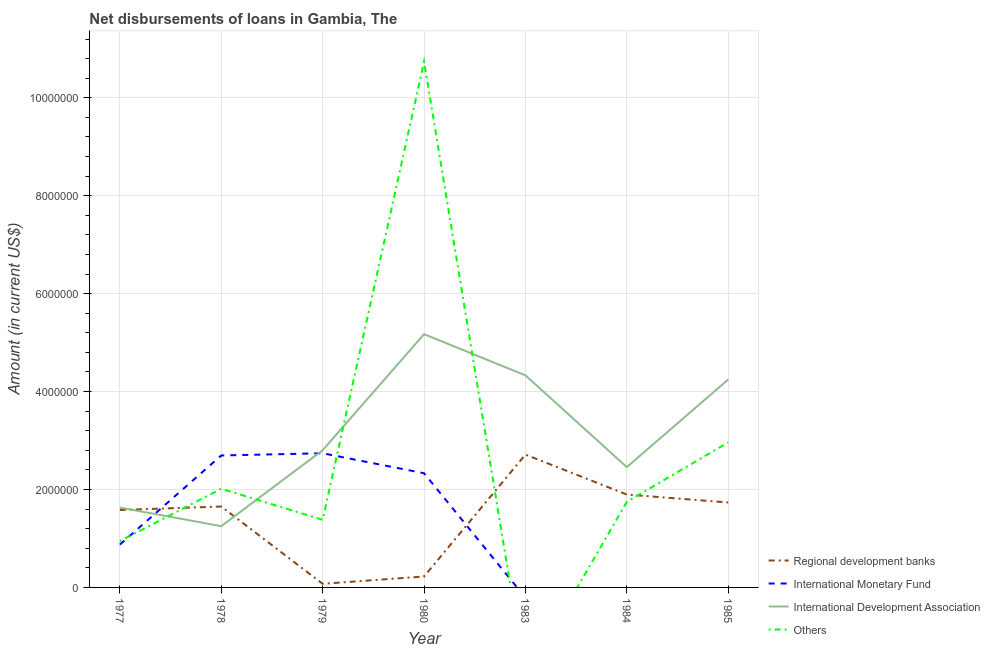How many different coloured lines are there?
Make the answer very short. 4. Is the number of lines equal to the number of legend labels?
Your answer should be compact. No. What is the amount of loan disimbursed by other organisations in 1978?
Your answer should be very brief. 2.02e+06. Across all years, what is the maximum amount of loan disimbursed by regional development banks?
Ensure brevity in your answer.  2.71e+06. In which year was the amount of loan disimbursed by international development association maximum?
Offer a very short reply. 1980. What is the total amount of loan disimbursed by other organisations in the graph?
Keep it short and to the point. 1.98e+07. What is the difference between the amount of loan disimbursed by international development association in 1978 and that in 1985?
Provide a succinct answer. -3.00e+06. What is the difference between the amount of loan disimbursed by other organisations in 1984 and the amount of loan disimbursed by regional development banks in 1983?
Provide a short and direct response. -9.65e+05. What is the average amount of loan disimbursed by international monetary fund per year?
Your answer should be compact. 1.23e+06. In the year 1979, what is the difference between the amount of loan disimbursed by other organisations and amount of loan disimbursed by international monetary fund?
Keep it short and to the point. -1.36e+06. What is the ratio of the amount of loan disimbursed by regional development banks in 1979 to that in 1984?
Give a very brief answer. 0.04. Is the amount of loan disimbursed by international development association in 1977 less than that in 1983?
Ensure brevity in your answer.  Yes. What is the difference between the highest and the second highest amount of loan disimbursed by other organisations?
Ensure brevity in your answer.  7.78e+06. What is the difference between the highest and the lowest amount of loan disimbursed by international monetary fund?
Keep it short and to the point. 2.74e+06. Does the amount of loan disimbursed by international development association monotonically increase over the years?
Keep it short and to the point. No. Is the amount of loan disimbursed by international monetary fund strictly greater than the amount of loan disimbursed by regional development banks over the years?
Provide a short and direct response. No. How many lines are there?
Offer a very short reply. 4. Are the values on the major ticks of Y-axis written in scientific E-notation?
Offer a terse response. No. Where does the legend appear in the graph?
Provide a short and direct response. Bottom right. How are the legend labels stacked?
Keep it short and to the point. Vertical. What is the title of the graph?
Ensure brevity in your answer.  Net disbursements of loans in Gambia, The. What is the label or title of the X-axis?
Your answer should be very brief. Year. What is the Amount (in current US$) in Regional development banks in 1977?
Keep it short and to the point. 1.58e+06. What is the Amount (in current US$) of International Monetary Fund in 1977?
Your answer should be compact. 8.75e+05. What is the Amount (in current US$) of International Development Association in 1977?
Provide a short and direct response. 1.63e+06. What is the Amount (in current US$) in Others in 1977?
Provide a short and direct response. 9.45e+05. What is the Amount (in current US$) in Regional development banks in 1978?
Provide a succinct answer. 1.65e+06. What is the Amount (in current US$) of International Monetary Fund in 1978?
Your response must be concise. 2.70e+06. What is the Amount (in current US$) in International Development Association in 1978?
Offer a very short reply. 1.25e+06. What is the Amount (in current US$) of Others in 1978?
Ensure brevity in your answer.  2.02e+06. What is the Amount (in current US$) in Regional development banks in 1979?
Offer a terse response. 7.40e+04. What is the Amount (in current US$) in International Monetary Fund in 1979?
Keep it short and to the point. 2.74e+06. What is the Amount (in current US$) in International Development Association in 1979?
Your answer should be compact. 2.80e+06. What is the Amount (in current US$) of Others in 1979?
Offer a very short reply. 1.38e+06. What is the Amount (in current US$) in Regional development banks in 1980?
Offer a very short reply. 2.23e+05. What is the Amount (in current US$) of International Monetary Fund in 1980?
Your response must be concise. 2.33e+06. What is the Amount (in current US$) of International Development Association in 1980?
Give a very brief answer. 5.17e+06. What is the Amount (in current US$) of Others in 1980?
Offer a very short reply. 1.07e+07. What is the Amount (in current US$) in Regional development banks in 1983?
Offer a very short reply. 2.71e+06. What is the Amount (in current US$) of International Monetary Fund in 1983?
Ensure brevity in your answer.  0. What is the Amount (in current US$) in International Development Association in 1983?
Provide a succinct answer. 4.33e+06. What is the Amount (in current US$) of Others in 1983?
Make the answer very short. 0. What is the Amount (in current US$) in Regional development banks in 1984?
Provide a succinct answer. 1.90e+06. What is the Amount (in current US$) of International Development Association in 1984?
Offer a terse response. 2.46e+06. What is the Amount (in current US$) in Others in 1984?
Offer a very short reply. 1.75e+06. What is the Amount (in current US$) of Regional development banks in 1985?
Provide a short and direct response. 1.74e+06. What is the Amount (in current US$) of International Monetary Fund in 1985?
Make the answer very short. 0. What is the Amount (in current US$) of International Development Association in 1985?
Make the answer very short. 4.25e+06. What is the Amount (in current US$) of Others in 1985?
Give a very brief answer. 2.96e+06. Across all years, what is the maximum Amount (in current US$) of Regional development banks?
Offer a terse response. 2.71e+06. Across all years, what is the maximum Amount (in current US$) in International Monetary Fund?
Offer a very short reply. 2.74e+06. Across all years, what is the maximum Amount (in current US$) in International Development Association?
Your response must be concise. 5.17e+06. Across all years, what is the maximum Amount (in current US$) of Others?
Your response must be concise. 1.07e+07. Across all years, what is the minimum Amount (in current US$) of Regional development banks?
Provide a succinct answer. 7.40e+04. Across all years, what is the minimum Amount (in current US$) of International Development Association?
Keep it short and to the point. 1.25e+06. Across all years, what is the minimum Amount (in current US$) of Others?
Your answer should be compact. 0. What is the total Amount (in current US$) in Regional development banks in the graph?
Ensure brevity in your answer.  9.88e+06. What is the total Amount (in current US$) in International Monetary Fund in the graph?
Ensure brevity in your answer.  8.64e+06. What is the total Amount (in current US$) of International Development Association in the graph?
Your answer should be compact. 2.19e+07. What is the total Amount (in current US$) of Others in the graph?
Provide a short and direct response. 1.98e+07. What is the difference between the Amount (in current US$) of International Monetary Fund in 1977 and that in 1978?
Make the answer very short. -1.82e+06. What is the difference between the Amount (in current US$) of International Development Association in 1977 and that in 1978?
Offer a terse response. 3.80e+05. What is the difference between the Amount (in current US$) in Others in 1977 and that in 1978?
Your answer should be compact. -1.07e+06. What is the difference between the Amount (in current US$) of Regional development banks in 1977 and that in 1979?
Your answer should be compact. 1.51e+06. What is the difference between the Amount (in current US$) of International Monetary Fund in 1977 and that in 1979?
Make the answer very short. -1.86e+06. What is the difference between the Amount (in current US$) in International Development Association in 1977 and that in 1979?
Make the answer very short. -1.17e+06. What is the difference between the Amount (in current US$) in Others in 1977 and that in 1979?
Give a very brief answer. -4.36e+05. What is the difference between the Amount (in current US$) of Regional development banks in 1977 and that in 1980?
Give a very brief answer. 1.36e+06. What is the difference between the Amount (in current US$) of International Monetary Fund in 1977 and that in 1980?
Offer a terse response. -1.46e+06. What is the difference between the Amount (in current US$) of International Development Association in 1977 and that in 1980?
Provide a succinct answer. -3.54e+06. What is the difference between the Amount (in current US$) in Others in 1977 and that in 1980?
Offer a terse response. -9.79e+06. What is the difference between the Amount (in current US$) of Regional development banks in 1977 and that in 1983?
Keep it short and to the point. -1.13e+06. What is the difference between the Amount (in current US$) of International Development Association in 1977 and that in 1983?
Provide a short and direct response. -2.70e+06. What is the difference between the Amount (in current US$) in Regional development banks in 1977 and that in 1984?
Keep it short and to the point. -3.15e+05. What is the difference between the Amount (in current US$) of International Development Association in 1977 and that in 1984?
Ensure brevity in your answer.  -8.26e+05. What is the difference between the Amount (in current US$) of Others in 1977 and that in 1984?
Ensure brevity in your answer.  -8.03e+05. What is the difference between the Amount (in current US$) in Regional development banks in 1977 and that in 1985?
Offer a terse response. -1.53e+05. What is the difference between the Amount (in current US$) of International Development Association in 1977 and that in 1985?
Keep it short and to the point. -2.62e+06. What is the difference between the Amount (in current US$) in Others in 1977 and that in 1985?
Your answer should be compact. -2.02e+06. What is the difference between the Amount (in current US$) of Regional development banks in 1978 and that in 1979?
Offer a very short reply. 1.58e+06. What is the difference between the Amount (in current US$) in International Monetary Fund in 1978 and that in 1979?
Provide a short and direct response. -4.50e+04. What is the difference between the Amount (in current US$) in International Development Association in 1978 and that in 1979?
Provide a succinct answer. -1.55e+06. What is the difference between the Amount (in current US$) in Others in 1978 and that in 1979?
Offer a very short reply. 6.34e+05. What is the difference between the Amount (in current US$) in Regional development banks in 1978 and that in 1980?
Your answer should be compact. 1.43e+06. What is the difference between the Amount (in current US$) in International Monetary Fund in 1978 and that in 1980?
Offer a terse response. 3.63e+05. What is the difference between the Amount (in current US$) of International Development Association in 1978 and that in 1980?
Give a very brief answer. -3.92e+06. What is the difference between the Amount (in current US$) in Others in 1978 and that in 1980?
Your response must be concise. -8.72e+06. What is the difference between the Amount (in current US$) of Regional development banks in 1978 and that in 1983?
Offer a very short reply. -1.06e+06. What is the difference between the Amount (in current US$) in International Development Association in 1978 and that in 1983?
Offer a very short reply. -3.08e+06. What is the difference between the Amount (in current US$) of Regional development banks in 1978 and that in 1984?
Provide a succinct answer. -2.45e+05. What is the difference between the Amount (in current US$) in International Development Association in 1978 and that in 1984?
Keep it short and to the point. -1.21e+06. What is the difference between the Amount (in current US$) in Others in 1978 and that in 1984?
Your answer should be compact. 2.67e+05. What is the difference between the Amount (in current US$) of Regional development banks in 1978 and that in 1985?
Your answer should be compact. -8.30e+04. What is the difference between the Amount (in current US$) in International Development Association in 1978 and that in 1985?
Provide a succinct answer. -3.00e+06. What is the difference between the Amount (in current US$) in Others in 1978 and that in 1985?
Provide a succinct answer. -9.48e+05. What is the difference between the Amount (in current US$) in Regional development banks in 1979 and that in 1980?
Make the answer very short. -1.49e+05. What is the difference between the Amount (in current US$) of International Monetary Fund in 1979 and that in 1980?
Your answer should be very brief. 4.08e+05. What is the difference between the Amount (in current US$) of International Development Association in 1979 and that in 1980?
Give a very brief answer. -2.37e+06. What is the difference between the Amount (in current US$) in Others in 1979 and that in 1980?
Keep it short and to the point. -9.36e+06. What is the difference between the Amount (in current US$) in Regional development banks in 1979 and that in 1983?
Keep it short and to the point. -2.64e+06. What is the difference between the Amount (in current US$) in International Development Association in 1979 and that in 1983?
Keep it short and to the point. -1.53e+06. What is the difference between the Amount (in current US$) in Regional development banks in 1979 and that in 1984?
Keep it short and to the point. -1.82e+06. What is the difference between the Amount (in current US$) of International Development Association in 1979 and that in 1984?
Provide a succinct answer. 3.46e+05. What is the difference between the Amount (in current US$) in Others in 1979 and that in 1984?
Keep it short and to the point. -3.67e+05. What is the difference between the Amount (in current US$) of Regional development banks in 1979 and that in 1985?
Your answer should be very brief. -1.66e+06. What is the difference between the Amount (in current US$) in International Development Association in 1979 and that in 1985?
Ensure brevity in your answer.  -1.44e+06. What is the difference between the Amount (in current US$) in Others in 1979 and that in 1985?
Your response must be concise. -1.58e+06. What is the difference between the Amount (in current US$) of Regional development banks in 1980 and that in 1983?
Make the answer very short. -2.49e+06. What is the difference between the Amount (in current US$) in International Development Association in 1980 and that in 1983?
Offer a terse response. 8.41e+05. What is the difference between the Amount (in current US$) of Regional development banks in 1980 and that in 1984?
Make the answer very short. -1.67e+06. What is the difference between the Amount (in current US$) of International Development Association in 1980 and that in 1984?
Make the answer very short. 2.72e+06. What is the difference between the Amount (in current US$) in Others in 1980 and that in 1984?
Provide a succinct answer. 8.99e+06. What is the difference between the Amount (in current US$) in Regional development banks in 1980 and that in 1985?
Offer a very short reply. -1.51e+06. What is the difference between the Amount (in current US$) in International Development Association in 1980 and that in 1985?
Your response must be concise. 9.25e+05. What is the difference between the Amount (in current US$) of Others in 1980 and that in 1985?
Offer a very short reply. 7.78e+06. What is the difference between the Amount (in current US$) in Regional development banks in 1983 and that in 1984?
Make the answer very short. 8.16e+05. What is the difference between the Amount (in current US$) in International Development Association in 1983 and that in 1984?
Make the answer very short. 1.87e+06. What is the difference between the Amount (in current US$) in Regional development banks in 1983 and that in 1985?
Your answer should be very brief. 9.78e+05. What is the difference between the Amount (in current US$) in International Development Association in 1983 and that in 1985?
Offer a terse response. 8.40e+04. What is the difference between the Amount (in current US$) in Regional development banks in 1984 and that in 1985?
Offer a terse response. 1.62e+05. What is the difference between the Amount (in current US$) of International Development Association in 1984 and that in 1985?
Offer a terse response. -1.79e+06. What is the difference between the Amount (in current US$) in Others in 1984 and that in 1985?
Ensure brevity in your answer.  -1.22e+06. What is the difference between the Amount (in current US$) in Regional development banks in 1977 and the Amount (in current US$) in International Monetary Fund in 1978?
Provide a short and direct response. -1.11e+06. What is the difference between the Amount (in current US$) of Regional development banks in 1977 and the Amount (in current US$) of International Development Association in 1978?
Offer a terse response. 3.31e+05. What is the difference between the Amount (in current US$) in Regional development banks in 1977 and the Amount (in current US$) in Others in 1978?
Your response must be concise. -4.33e+05. What is the difference between the Amount (in current US$) of International Monetary Fund in 1977 and the Amount (in current US$) of International Development Association in 1978?
Your answer should be very brief. -3.76e+05. What is the difference between the Amount (in current US$) in International Monetary Fund in 1977 and the Amount (in current US$) in Others in 1978?
Your answer should be very brief. -1.14e+06. What is the difference between the Amount (in current US$) in International Development Association in 1977 and the Amount (in current US$) in Others in 1978?
Keep it short and to the point. -3.84e+05. What is the difference between the Amount (in current US$) in Regional development banks in 1977 and the Amount (in current US$) in International Monetary Fund in 1979?
Ensure brevity in your answer.  -1.16e+06. What is the difference between the Amount (in current US$) of Regional development banks in 1977 and the Amount (in current US$) of International Development Association in 1979?
Offer a terse response. -1.22e+06. What is the difference between the Amount (in current US$) of Regional development banks in 1977 and the Amount (in current US$) of Others in 1979?
Give a very brief answer. 2.01e+05. What is the difference between the Amount (in current US$) in International Monetary Fund in 1977 and the Amount (in current US$) in International Development Association in 1979?
Make the answer very short. -1.93e+06. What is the difference between the Amount (in current US$) of International Monetary Fund in 1977 and the Amount (in current US$) of Others in 1979?
Provide a succinct answer. -5.06e+05. What is the difference between the Amount (in current US$) in International Development Association in 1977 and the Amount (in current US$) in Others in 1979?
Your answer should be compact. 2.50e+05. What is the difference between the Amount (in current US$) in Regional development banks in 1977 and the Amount (in current US$) in International Monetary Fund in 1980?
Your response must be concise. -7.50e+05. What is the difference between the Amount (in current US$) in Regional development banks in 1977 and the Amount (in current US$) in International Development Association in 1980?
Provide a short and direct response. -3.59e+06. What is the difference between the Amount (in current US$) of Regional development banks in 1977 and the Amount (in current US$) of Others in 1980?
Your response must be concise. -9.16e+06. What is the difference between the Amount (in current US$) in International Monetary Fund in 1977 and the Amount (in current US$) in International Development Association in 1980?
Ensure brevity in your answer.  -4.30e+06. What is the difference between the Amount (in current US$) of International Monetary Fund in 1977 and the Amount (in current US$) of Others in 1980?
Ensure brevity in your answer.  -9.86e+06. What is the difference between the Amount (in current US$) of International Development Association in 1977 and the Amount (in current US$) of Others in 1980?
Your response must be concise. -9.11e+06. What is the difference between the Amount (in current US$) of Regional development banks in 1977 and the Amount (in current US$) of International Development Association in 1983?
Your response must be concise. -2.75e+06. What is the difference between the Amount (in current US$) in International Monetary Fund in 1977 and the Amount (in current US$) in International Development Association in 1983?
Offer a very short reply. -3.46e+06. What is the difference between the Amount (in current US$) of Regional development banks in 1977 and the Amount (in current US$) of International Development Association in 1984?
Offer a very short reply. -8.75e+05. What is the difference between the Amount (in current US$) of Regional development banks in 1977 and the Amount (in current US$) of Others in 1984?
Your response must be concise. -1.66e+05. What is the difference between the Amount (in current US$) of International Monetary Fund in 1977 and the Amount (in current US$) of International Development Association in 1984?
Keep it short and to the point. -1.58e+06. What is the difference between the Amount (in current US$) in International Monetary Fund in 1977 and the Amount (in current US$) in Others in 1984?
Your answer should be very brief. -8.73e+05. What is the difference between the Amount (in current US$) of International Development Association in 1977 and the Amount (in current US$) of Others in 1984?
Provide a succinct answer. -1.17e+05. What is the difference between the Amount (in current US$) of Regional development banks in 1977 and the Amount (in current US$) of International Development Association in 1985?
Give a very brief answer. -2.66e+06. What is the difference between the Amount (in current US$) in Regional development banks in 1977 and the Amount (in current US$) in Others in 1985?
Offer a very short reply. -1.38e+06. What is the difference between the Amount (in current US$) in International Monetary Fund in 1977 and the Amount (in current US$) in International Development Association in 1985?
Provide a short and direct response. -3.37e+06. What is the difference between the Amount (in current US$) of International Monetary Fund in 1977 and the Amount (in current US$) of Others in 1985?
Give a very brief answer. -2.09e+06. What is the difference between the Amount (in current US$) of International Development Association in 1977 and the Amount (in current US$) of Others in 1985?
Your answer should be compact. -1.33e+06. What is the difference between the Amount (in current US$) of Regional development banks in 1978 and the Amount (in current US$) of International Monetary Fund in 1979?
Give a very brief answer. -1.09e+06. What is the difference between the Amount (in current US$) of Regional development banks in 1978 and the Amount (in current US$) of International Development Association in 1979?
Offer a terse response. -1.15e+06. What is the difference between the Amount (in current US$) in Regional development banks in 1978 and the Amount (in current US$) in Others in 1979?
Make the answer very short. 2.71e+05. What is the difference between the Amount (in current US$) in International Monetary Fund in 1978 and the Amount (in current US$) in International Development Association in 1979?
Provide a succinct answer. -1.08e+05. What is the difference between the Amount (in current US$) in International Monetary Fund in 1978 and the Amount (in current US$) in Others in 1979?
Offer a terse response. 1.31e+06. What is the difference between the Amount (in current US$) of International Development Association in 1978 and the Amount (in current US$) of Others in 1979?
Provide a short and direct response. -1.30e+05. What is the difference between the Amount (in current US$) of Regional development banks in 1978 and the Amount (in current US$) of International Monetary Fund in 1980?
Make the answer very short. -6.80e+05. What is the difference between the Amount (in current US$) of Regional development banks in 1978 and the Amount (in current US$) of International Development Association in 1980?
Your answer should be compact. -3.52e+06. What is the difference between the Amount (in current US$) of Regional development banks in 1978 and the Amount (in current US$) of Others in 1980?
Keep it short and to the point. -9.09e+06. What is the difference between the Amount (in current US$) in International Monetary Fund in 1978 and the Amount (in current US$) in International Development Association in 1980?
Your answer should be very brief. -2.48e+06. What is the difference between the Amount (in current US$) of International Monetary Fund in 1978 and the Amount (in current US$) of Others in 1980?
Your response must be concise. -8.04e+06. What is the difference between the Amount (in current US$) in International Development Association in 1978 and the Amount (in current US$) in Others in 1980?
Your answer should be very brief. -9.49e+06. What is the difference between the Amount (in current US$) in Regional development banks in 1978 and the Amount (in current US$) in International Development Association in 1983?
Provide a succinct answer. -2.68e+06. What is the difference between the Amount (in current US$) of International Monetary Fund in 1978 and the Amount (in current US$) of International Development Association in 1983?
Provide a short and direct response. -1.64e+06. What is the difference between the Amount (in current US$) in Regional development banks in 1978 and the Amount (in current US$) in International Development Association in 1984?
Ensure brevity in your answer.  -8.05e+05. What is the difference between the Amount (in current US$) of Regional development banks in 1978 and the Amount (in current US$) of Others in 1984?
Provide a succinct answer. -9.60e+04. What is the difference between the Amount (in current US$) of International Monetary Fund in 1978 and the Amount (in current US$) of International Development Association in 1984?
Provide a succinct answer. 2.38e+05. What is the difference between the Amount (in current US$) in International Monetary Fund in 1978 and the Amount (in current US$) in Others in 1984?
Provide a short and direct response. 9.47e+05. What is the difference between the Amount (in current US$) in International Development Association in 1978 and the Amount (in current US$) in Others in 1984?
Your answer should be very brief. -4.97e+05. What is the difference between the Amount (in current US$) of Regional development banks in 1978 and the Amount (in current US$) of International Development Association in 1985?
Provide a succinct answer. -2.60e+06. What is the difference between the Amount (in current US$) of Regional development banks in 1978 and the Amount (in current US$) of Others in 1985?
Keep it short and to the point. -1.31e+06. What is the difference between the Amount (in current US$) in International Monetary Fund in 1978 and the Amount (in current US$) in International Development Association in 1985?
Provide a short and direct response. -1.55e+06. What is the difference between the Amount (in current US$) in International Monetary Fund in 1978 and the Amount (in current US$) in Others in 1985?
Give a very brief answer. -2.68e+05. What is the difference between the Amount (in current US$) of International Development Association in 1978 and the Amount (in current US$) of Others in 1985?
Provide a short and direct response. -1.71e+06. What is the difference between the Amount (in current US$) in Regional development banks in 1979 and the Amount (in current US$) in International Monetary Fund in 1980?
Offer a very short reply. -2.26e+06. What is the difference between the Amount (in current US$) of Regional development banks in 1979 and the Amount (in current US$) of International Development Association in 1980?
Offer a terse response. -5.10e+06. What is the difference between the Amount (in current US$) in Regional development banks in 1979 and the Amount (in current US$) in Others in 1980?
Make the answer very short. -1.07e+07. What is the difference between the Amount (in current US$) in International Monetary Fund in 1979 and the Amount (in current US$) in International Development Association in 1980?
Your answer should be very brief. -2.43e+06. What is the difference between the Amount (in current US$) of International Monetary Fund in 1979 and the Amount (in current US$) of Others in 1980?
Ensure brevity in your answer.  -8.00e+06. What is the difference between the Amount (in current US$) in International Development Association in 1979 and the Amount (in current US$) in Others in 1980?
Give a very brief answer. -7.94e+06. What is the difference between the Amount (in current US$) of Regional development banks in 1979 and the Amount (in current US$) of International Development Association in 1983?
Provide a succinct answer. -4.26e+06. What is the difference between the Amount (in current US$) of International Monetary Fund in 1979 and the Amount (in current US$) of International Development Association in 1983?
Your answer should be very brief. -1.59e+06. What is the difference between the Amount (in current US$) in Regional development banks in 1979 and the Amount (in current US$) in International Development Association in 1984?
Keep it short and to the point. -2.38e+06. What is the difference between the Amount (in current US$) of Regional development banks in 1979 and the Amount (in current US$) of Others in 1984?
Offer a terse response. -1.67e+06. What is the difference between the Amount (in current US$) of International Monetary Fund in 1979 and the Amount (in current US$) of International Development Association in 1984?
Your answer should be compact. 2.83e+05. What is the difference between the Amount (in current US$) of International Monetary Fund in 1979 and the Amount (in current US$) of Others in 1984?
Make the answer very short. 9.92e+05. What is the difference between the Amount (in current US$) in International Development Association in 1979 and the Amount (in current US$) in Others in 1984?
Your answer should be very brief. 1.06e+06. What is the difference between the Amount (in current US$) in Regional development banks in 1979 and the Amount (in current US$) in International Development Association in 1985?
Offer a terse response. -4.17e+06. What is the difference between the Amount (in current US$) in Regional development banks in 1979 and the Amount (in current US$) in Others in 1985?
Keep it short and to the point. -2.89e+06. What is the difference between the Amount (in current US$) in International Monetary Fund in 1979 and the Amount (in current US$) in International Development Association in 1985?
Your answer should be very brief. -1.51e+06. What is the difference between the Amount (in current US$) of International Monetary Fund in 1979 and the Amount (in current US$) of Others in 1985?
Keep it short and to the point. -2.23e+05. What is the difference between the Amount (in current US$) of Regional development banks in 1980 and the Amount (in current US$) of International Development Association in 1983?
Ensure brevity in your answer.  -4.11e+06. What is the difference between the Amount (in current US$) of International Monetary Fund in 1980 and the Amount (in current US$) of International Development Association in 1983?
Your response must be concise. -2.00e+06. What is the difference between the Amount (in current US$) of Regional development banks in 1980 and the Amount (in current US$) of International Development Association in 1984?
Your response must be concise. -2.23e+06. What is the difference between the Amount (in current US$) in Regional development banks in 1980 and the Amount (in current US$) in Others in 1984?
Your response must be concise. -1.52e+06. What is the difference between the Amount (in current US$) in International Monetary Fund in 1980 and the Amount (in current US$) in International Development Association in 1984?
Give a very brief answer. -1.25e+05. What is the difference between the Amount (in current US$) of International Monetary Fund in 1980 and the Amount (in current US$) of Others in 1984?
Your answer should be compact. 5.84e+05. What is the difference between the Amount (in current US$) of International Development Association in 1980 and the Amount (in current US$) of Others in 1984?
Make the answer very short. 3.42e+06. What is the difference between the Amount (in current US$) of Regional development banks in 1980 and the Amount (in current US$) of International Development Association in 1985?
Provide a succinct answer. -4.02e+06. What is the difference between the Amount (in current US$) in Regional development banks in 1980 and the Amount (in current US$) in Others in 1985?
Offer a very short reply. -2.74e+06. What is the difference between the Amount (in current US$) of International Monetary Fund in 1980 and the Amount (in current US$) of International Development Association in 1985?
Provide a succinct answer. -1.92e+06. What is the difference between the Amount (in current US$) in International Monetary Fund in 1980 and the Amount (in current US$) in Others in 1985?
Your answer should be very brief. -6.31e+05. What is the difference between the Amount (in current US$) in International Development Association in 1980 and the Amount (in current US$) in Others in 1985?
Offer a terse response. 2.21e+06. What is the difference between the Amount (in current US$) of Regional development banks in 1983 and the Amount (in current US$) of International Development Association in 1984?
Your answer should be compact. 2.56e+05. What is the difference between the Amount (in current US$) in Regional development banks in 1983 and the Amount (in current US$) in Others in 1984?
Make the answer very short. 9.65e+05. What is the difference between the Amount (in current US$) of International Development Association in 1983 and the Amount (in current US$) of Others in 1984?
Provide a succinct answer. 2.58e+06. What is the difference between the Amount (in current US$) in Regional development banks in 1983 and the Amount (in current US$) in International Development Association in 1985?
Offer a terse response. -1.53e+06. What is the difference between the Amount (in current US$) of International Development Association in 1983 and the Amount (in current US$) of Others in 1985?
Your answer should be very brief. 1.37e+06. What is the difference between the Amount (in current US$) in Regional development banks in 1984 and the Amount (in current US$) in International Development Association in 1985?
Your response must be concise. -2.35e+06. What is the difference between the Amount (in current US$) in Regional development banks in 1984 and the Amount (in current US$) in Others in 1985?
Your answer should be compact. -1.07e+06. What is the difference between the Amount (in current US$) in International Development Association in 1984 and the Amount (in current US$) in Others in 1985?
Keep it short and to the point. -5.06e+05. What is the average Amount (in current US$) of Regional development banks per year?
Your response must be concise. 1.41e+06. What is the average Amount (in current US$) in International Monetary Fund per year?
Offer a terse response. 1.23e+06. What is the average Amount (in current US$) of International Development Association per year?
Make the answer very short. 3.13e+06. What is the average Amount (in current US$) in Others per year?
Your answer should be very brief. 2.83e+06. In the year 1977, what is the difference between the Amount (in current US$) in Regional development banks and Amount (in current US$) in International Monetary Fund?
Provide a succinct answer. 7.07e+05. In the year 1977, what is the difference between the Amount (in current US$) of Regional development banks and Amount (in current US$) of International Development Association?
Your answer should be compact. -4.90e+04. In the year 1977, what is the difference between the Amount (in current US$) in Regional development banks and Amount (in current US$) in Others?
Your response must be concise. 6.37e+05. In the year 1977, what is the difference between the Amount (in current US$) of International Monetary Fund and Amount (in current US$) of International Development Association?
Ensure brevity in your answer.  -7.56e+05. In the year 1977, what is the difference between the Amount (in current US$) of International Monetary Fund and Amount (in current US$) of Others?
Your answer should be very brief. -7.00e+04. In the year 1977, what is the difference between the Amount (in current US$) of International Development Association and Amount (in current US$) of Others?
Provide a succinct answer. 6.86e+05. In the year 1978, what is the difference between the Amount (in current US$) in Regional development banks and Amount (in current US$) in International Monetary Fund?
Offer a terse response. -1.04e+06. In the year 1978, what is the difference between the Amount (in current US$) of Regional development banks and Amount (in current US$) of International Development Association?
Ensure brevity in your answer.  4.01e+05. In the year 1978, what is the difference between the Amount (in current US$) in Regional development banks and Amount (in current US$) in Others?
Offer a terse response. -3.63e+05. In the year 1978, what is the difference between the Amount (in current US$) of International Monetary Fund and Amount (in current US$) of International Development Association?
Your response must be concise. 1.44e+06. In the year 1978, what is the difference between the Amount (in current US$) in International Monetary Fund and Amount (in current US$) in Others?
Your answer should be compact. 6.80e+05. In the year 1978, what is the difference between the Amount (in current US$) of International Development Association and Amount (in current US$) of Others?
Provide a succinct answer. -7.64e+05. In the year 1979, what is the difference between the Amount (in current US$) of Regional development banks and Amount (in current US$) of International Monetary Fund?
Offer a very short reply. -2.67e+06. In the year 1979, what is the difference between the Amount (in current US$) of Regional development banks and Amount (in current US$) of International Development Association?
Keep it short and to the point. -2.73e+06. In the year 1979, what is the difference between the Amount (in current US$) of Regional development banks and Amount (in current US$) of Others?
Provide a succinct answer. -1.31e+06. In the year 1979, what is the difference between the Amount (in current US$) of International Monetary Fund and Amount (in current US$) of International Development Association?
Offer a terse response. -6.30e+04. In the year 1979, what is the difference between the Amount (in current US$) in International Monetary Fund and Amount (in current US$) in Others?
Provide a short and direct response. 1.36e+06. In the year 1979, what is the difference between the Amount (in current US$) in International Development Association and Amount (in current US$) in Others?
Your response must be concise. 1.42e+06. In the year 1980, what is the difference between the Amount (in current US$) of Regional development banks and Amount (in current US$) of International Monetary Fund?
Make the answer very short. -2.11e+06. In the year 1980, what is the difference between the Amount (in current US$) of Regional development banks and Amount (in current US$) of International Development Association?
Your answer should be very brief. -4.95e+06. In the year 1980, what is the difference between the Amount (in current US$) of Regional development banks and Amount (in current US$) of Others?
Offer a very short reply. -1.05e+07. In the year 1980, what is the difference between the Amount (in current US$) of International Monetary Fund and Amount (in current US$) of International Development Association?
Make the answer very short. -2.84e+06. In the year 1980, what is the difference between the Amount (in current US$) of International Monetary Fund and Amount (in current US$) of Others?
Provide a succinct answer. -8.41e+06. In the year 1980, what is the difference between the Amount (in current US$) in International Development Association and Amount (in current US$) in Others?
Ensure brevity in your answer.  -5.57e+06. In the year 1983, what is the difference between the Amount (in current US$) of Regional development banks and Amount (in current US$) of International Development Association?
Provide a short and direct response. -1.62e+06. In the year 1984, what is the difference between the Amount (in current US$) of Regional development banks and Amount (in current US$) of International Development Association?
Make the answer very short. -5.60e+05. In the year 1984, what is the difference between the Amount (in current US$) in Regional development banks and Amount (in current US$) in Others?
Give a very brief answer. 1.49e+05. In the year 1984, what is the difference between the Amount (in current US$) of International Development Association and Amount (in current US$) of Others?
Ensure brevity in your answer.  7.09e+05. In the year 1985, what is the difference between the Amount (in current US$) of Regional development banks and Amount (in current US$) of International Development Association?
Provide a succinct answer. -2.51e+06. In the year 1985, what is the difference between the Amount (in current US$) of Regional development banks and Amount (in current US$) of Others?
Provide a succinct answer. -1.23e+06. In the year 1985, what is the difference between the Amount (in current US$) in International Development Association and Amount (in current US$) in Others?
Your answer should be very brief. 1.28e+06. What is the ratio of the Amount (in current US$) of Regional development banks in 1977 to that in 1978?
Offer a very short reply. 0.96. What is the ratio of the Amount (in current US$) of International Monetary Fund in 1977 to that in 1978?
Offer a very short reply. 0.32. What is the ratio of the Amount (in current US$) of International Development Association in 1977 to that in 1978?
Your response must be concise. 1.3. What is the ratio of the Amount (in current US$) in Others in 1977 to that in 1978?
Your answer should be compact. 0.47. What is the ratio of the Amount (in current US$) in Regional development banks in 1977 to that in 1979?
Ensure brevity in your answer.  21.38. What is the ratio of the Amount (in current US$) of International Monetary Fund in 1977 to that in 1979?
Your answer should be compact. 0.32. What is the ratio of the Amount (in current US$) in International Development Association in 1977 to that in 1979?
Your response must be concise. 0.58. What is the ratio of the Amount (in current US$) of Others in 1977 to that in 1979?
Your answer should be very brief. 0.68. What is the ratio of the Amount (in current US$) of Regional development banks in 1977 to that in 1980?
Keep it short and to the point. 7.09. What is the ratio of the Amount (in current US$) in International Monetary Fund in 1977 to that in 1980?
Give a very brief answer. 0.38. What is the ratio of the Amount (in current US$) of International Development Association in 1977 to that in 1980?
Your answer should be compact. 0.32. What is the ratio of the Amount (in current US$) of Others in 1977 to that in 1980?
Ensure brevity in your answer.  0.09. What is the ratio of the Amount (in current US$) of Regional development banks in 1977 to that in 1983?
Give a very brief answer. 0.58. What is the ratio of the Amount (in current US$) in International Development Association in 1977 to that in 1983?
Make the answer very short. 0.38. What is the ratio of the Amount (in current US$) in Regional development banks in 1977 to that in 1984?
Your answer should be very brief. 0.83. What is the ratio of the Amount (in current US$) in International Development Association in 1977 to that in 1984?
Your answer should be very brief. 0.66. What is the ratio of the Amount (in current US$) in Others in 1977 to that in 1984?
Your answer should be very brief. 0.54. What is the ratio of the Amount (in current US$) of Regional development banks in 1977 to that in 1985?
Offer a very short reply. 0.91. What is the ratio of the Amount (in current US$) of International Development Association in 1977 to that in 1985?
Make the answer very short. 0.38. What is the ratio of the Amount (in current US$) in Others in 1977 to that in 1985?
Give a very brief answer. 0.32. What is the ratio of the Amount (in current US$) in Regional development banks in 1978 to that in 1979?
Provide a short and direct response. 22.32. What is the ratio of the Amount (in current US$) in International Monetary Fund in 1978 to that in 1979?
Give a very brief answer. 0.98. What is the ratio of the Amount (in current US$) in International Development Association in 1978 to that in 1979?
Provide a succinct answer. 0.45. What is the ratio of the Amount (in current US$) in Others in 1978 to that in 1979?
Keep it short and to the point. 1.46. What is the ratio of the Amount (in current US$) in Regional development banks in 1978 to that in 1980?
Keep it short and to the point. 7.41. What is the ratio of the Amount (in current US$) in International Monetary Fund in 1978 to that in 1980?
Your answer should be very brief. 1.16. What is the ratio of the Amount (in current US$) of International Development Association in 1978 to that in 1980?
Your answer should be very brief. 0.24. What is the ratio of the Amount (in current US$) in Others in 1978 to that in 1980?
Ensure brevity in your answer.  0.19. What is the ratio of the Amount (in current US$) in Regional development banks in 1978 to that in 1983?
Your response must be concise. 0.61. What is the ratio of the Amount (in current US$) of International Development Association in 1978 to that in 1983?
Offer a terse response. 0.29. What is the ratio of the Amount (in current US$) of Regional development banks in 1978 to that in 1984?
Your response must be concise. 0.87. What is the ratio of the Amount (in current US$) in International Development Association in 1978 to that in 1984?
Your answer should be compact. 0.51. What is the ratio of the Amount (in current US$) of Others in 1978 to that in 1984?
Your answer should be very brief. 1.15. What is the ratio of the Amount (in current US$) in Regional development banks in 1978 to that in 1985?
Provide a succinct answer. 0.95. What is the ratio of the Amount (in current US$) in International Development Association in 1978 to that in 1985?
Offer a terse response. 0.29. What is the ratio of the Amount (in current US$) of Others in 1978 to that in 1985?
Your answer should be compact. 0.68. What is the ratio of the Amount (in current US$) in Regional development banks in 1979 to that in 1980?
Provide a succinct answer. 0.33. What is the ratio of the Amount (in current US$) in International Monetary Fund in 1979 to that in 1980?
Offer a terse response. 1.18. What is the ratio of the Amount (in current US$) of International Development Association in 1979 to that in 1980?
Offer a very short reply. 0.54. What is the ratio of the Amount (in current US$) of Others in 1979 to that in 1980?
Give a very brief answer. 0.13. What is the ratio of the Amount (in current US$) of Regional development banks in 1979 to that in 1983?
Make the answer very short. 0.03. What is the ratio of the Amount (in current US$) in International Development Association in 1979 to that in 1983?
Provide a short and direct response. 0.65. What is the ratio of the Amount (in current US$) in Regional development banks in 1979 to that in 1984?
Offer a very short reply. 0.04. What is the ratio of the Amount (in current US$) of International Development Association in 1979 to that in 1984?
Your response must be concise. 1.14. What is the ratio of the Amount (in current US$) of Others in 1979 to that in 1984?
Offer a terse response. 0.79. What is the ratio of the Amount (in current US$) in Regional development banks in 1979 to that in 1985?
Ensure brevity in your answer.  0.04. What is the ratio of the Amount (in current US$) in International Development Association in 1979 to that in 1985?
Provide a succinct answer. 0.66. What is the ratio of the Amount (in current US$) of Others in 1979 to that in 1985?
Your response must be concise. 0.47. What is the ratio of the Amount (in current US$) of Regional development banks in 1980 to that in 1983?
Offer a terse response. 0.08. What is the ratio of the Amount (in current US$) in International Development Association in 1980 to that in 1983?
Offer a terse response. 1.19. What is the ratio of the Amount (in current US$) in Regional development banks in 1980 to that in 1984?
Your answer should be very brief. 0.12. What is the ratio of the Amount (in current US$) in International Development Association in 1980 to that in 1984?
Offer a terse response. 2.1. What is the ratio of the Amount (in current US$) in Others in 1980 to that in 1984?
Ensure brevity in your answer.  6.14. What is the ratio of the Amount (in current US$) in Regional development banks in 1980 to that in 1985?
Ensure brevity in your answer.  0.13. What is the ratio of the Amount (in current US$) of International Development Association in 1980 to that in 1985?
Offer a very short reply. 1.22. What is the ratio of the Amount (in current US$) in Others in 1980 to that in 1985?
Ensure brevity in your answer.  3.62. What is the ratio of the Amount (in current US$) of Regional development banks in 1983 to that in 1984?
Ensure brevity in your answer.  1.43. What is the ratio of the Amount (in current US$) of International Development Association in 1983 to that in 1984?
Provide a succinct answer. 1.76. What is the ratio of the Amount (in current US$) of Regional development banks in 1983 to that in 1985?
Ensure brevity in your answer.  1.56. What is the ratio of the Amount (in current US$) in International Development Association in 1983 to that in 1985?
Provide a short and direct response. 1.02. What is the ratio of the Amount (in current US$) of Regional development banks in 1984 to that in 1985?
Your answer should be compact. 1.09. What is the ratio of the Amount (in current US$) of International Development Association in 1984 to that in 1985?
Give a very brief answer. 0.58. What is the ratio of the Amount (in current US$) of Others in 1984 to that in 1985?
Keep it short and to the point. 0.59. What is the difference between the highest and the second highest Amount (in current US$) of Regional development banks?
Make the answer very short. 8.16e+05. What is the difference between the highest and the second highest Amount (in current US$) of International Monetary Fund?
Provide a succinct answer. 4.50e+04. What is the difference between the highest and the second highest Amount (in current US$) of International Development Association?
Give a very brief answer. 8.41e+05. What is the difference between the highest and the second highest Amount (in current US$) in Others?
Your answer should be compact. 7.78e+06. What is the difference between the highest and the lowest Amount (in current US$) in Regional development banks?
Make the answer very short. 2.64e+06. What is the difference between the highest and the lowest Amount (in current US$) in International Monetary Fund?
Offer a terse response. 2.74e+06. What is the difference between the highest and the lowest Amount (in current US$) in International Development Association?
Your answer should be compact. 3.92e+06. What is the difference between the highest and the lowest Amount (in current US$) of Others?
Your answer should be very brief. 1.07e+07. 